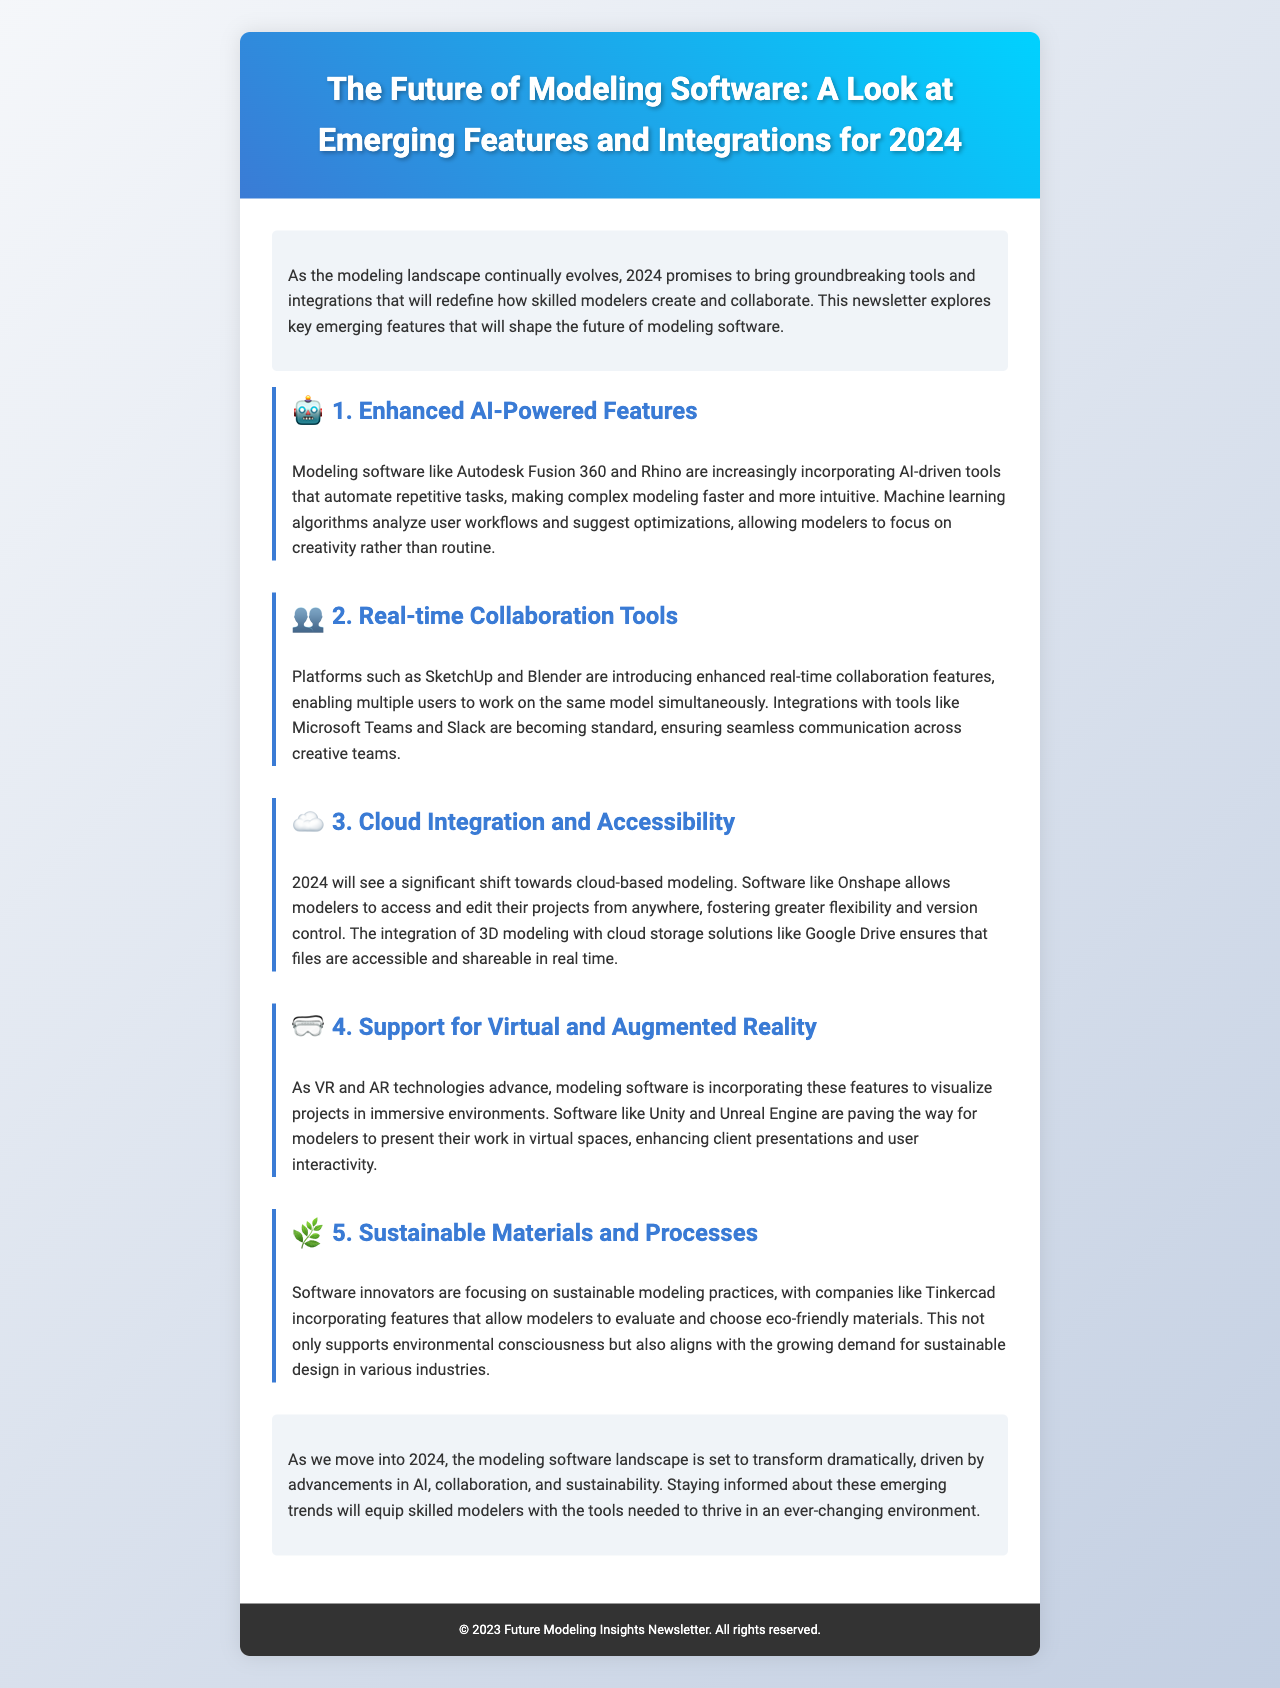What are the key emerging features in modeling software for 2024? The document outlines five key emerging features: Enhanced AI-Powered Features, Real-time Collaboration Tools, Cloud Integration and Accessibility, Support for Virtual and Augmented Reality, and Sustainable Materials and Processes.
Answer: Five Which software is mentioned for AI-Powered Features? The document specifically mentions Autodesk Fusion 360 and Rhino as incorporating AI-driven tools.
Answer: Autodesk Fusion 360, Rhino What is a benefit of cloud-based modeling mentioned in the newsletter? The document states that cloud-based modeling offers greater flexibility and version control for modelers.
Answer: Flexibility and version control Which technologies are emphasized for immersive visualization in modeling software? The newsletter highlights Virtual and Augmented Reality technologies as significant for visualization.
Answer: Virtual and Augmented Reality What type of tools are SketchUp and Blender introducing? The document discusses that SketchUp and Blender are enhancing real-time collaboration features.
Answer: Real-time collaboration features What year does the newsletter focus on for predicting changes in modeling software? The newsletter looks ahead to the year 2024 for the upcoming changes and innovations in modeling software.
Answer: 2024 Which company is making strides in sustainable modeling practices? Tinkercad is noted in the newsletter for incorporating features to evaluate and choose eco-friendly materials.
Answer: Tinkercad What is the primary theme of the newsletter? The newsletter centers around the future of modeling software, focusing on emerging trends and features for 2024.
Answer: Future of modeling software 